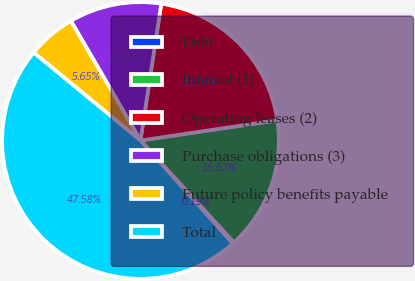Convert chart. <chart><loc_0><loc_0><loc_500><loc_500><pie_chart><fcel>Debt<fcel>Interest (1)<fcel>Operating leases (2)<fcel>Purchase obligations (3)<fcel>Future policy benefits payable<fcel>Total<nl><fcel>0.19%<fcel>15.52%<fcel>20.26%<fcel>10.79%<fcel>5.65%<fcel>47.58%<nl></chart> 